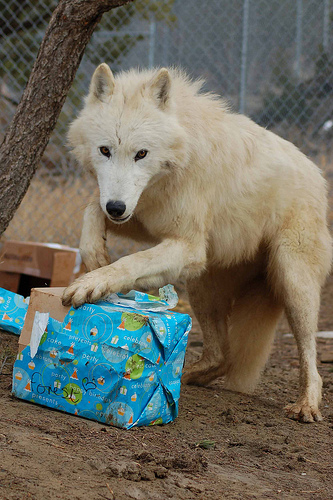<image>
Is there a wolf on the present? Yes. Looking at the image, I can see the wolf is positioned on top of the present, with the present providing support. Is the dog on the box? Yes. Looking at the image, I can see the dog is positioned on top of the box, with the box providing support. Is the dog on the paper box? Yes. Looking at the image, I can see the dog is positioned on top of the paper box, with the paper box providing support. Where is the dog in relation to the box? Is it next to the box? Yes. The dog is positioned adjacent to the box, located nearby in the same general area. 